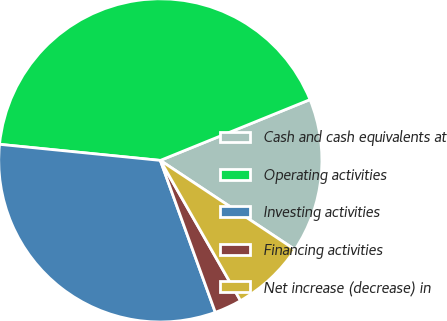Convert chart. <chart><loc_0><loc_0><loc_500><loc_500><pie_chart><fcel>Cash and cash equivalents at<fcel>Operating activities<fcel>Investing activities<fcel>Financing activities<fcel>Net increase (decrease) in<nl><fcel>15.45%<fcel>42.27%<fcel>32.11%<fcel>2.74%<fcel>7.42%<nl></chart> 